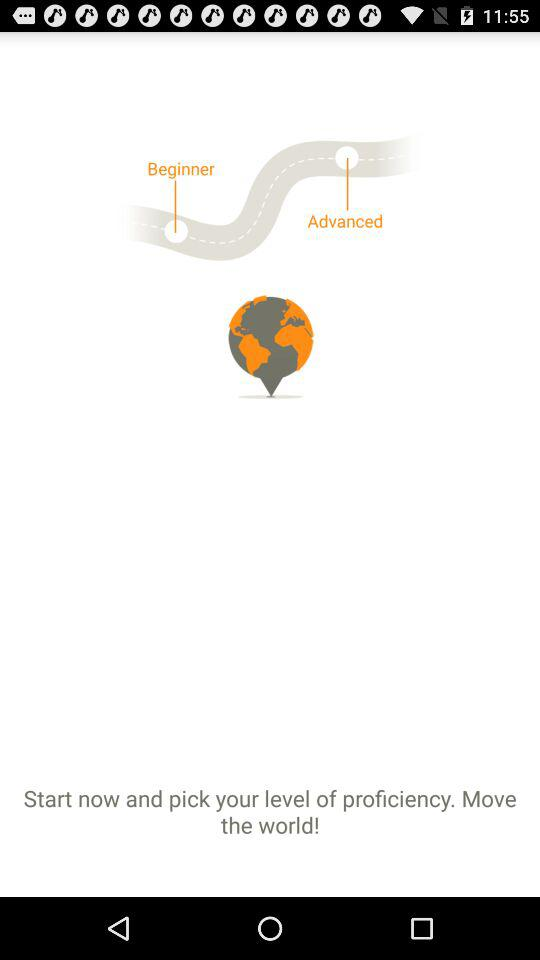How many stages are shown?
Answer the question using a single word or phrase. 2 